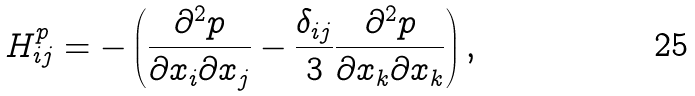<formula> <loc_0><loc_0><loc_500><loc_500>H _ { i j } ^ { p } = - \left ( \frac { \partial ^ { 2 } p } { \partial x _ { i } \partial x _ { j } } - \frac { \delta _ { i j } } { 3 } \frac { \partial ^ { 2 } p } { \partial x _ { k } \partial x _ { k } } \right ) ,</formula> 